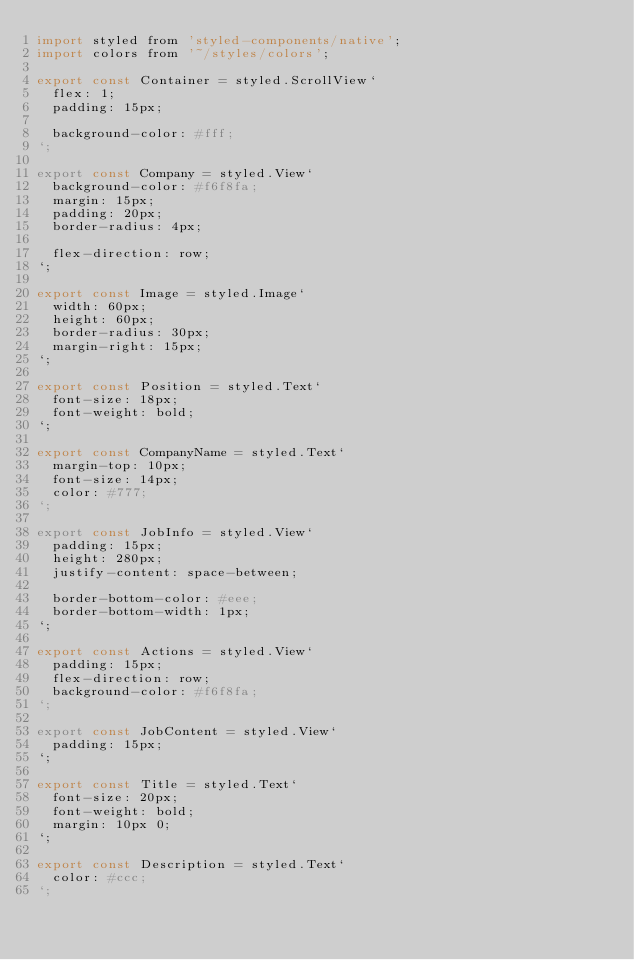<code> <loc_0><loc_0><loc_500><loc_500><_JavaScript_>import styled from 'styled-components/native';
import colors from '~/styles/colors';

export const Container = styled.ScrollView`
  flex: 1;
  padding: 15px;

  background-color: #fff;
`;

export const Company = styled.View`
  background-color: #f6f8fa;
  margin: 15px;
  padding: 20px;
  border-radius: 4px;

  flex-direction: row;
`;

export const Image = styled.Image`
  width: 60px;
  height: 60px;
  border-radius: 30px;
  margin-right: 15px;
`;

export const Position = styled.Text`
  font-size: 18px;
  font-weight: bold;
`;

export const CompanyName = styled.Text`
  margin-top: 10px;
  font-size: 14px;
  color: #777;
`;

export const JobInfo = styled.View`
  padding: 15px;
  height: 280px;
  justify-content: space-between;

  border-bottom-color: #eee;
  border-bottom-width: 1px;
`;

export const Actions = styled.View`
  padding: 15px;
  flex-direction: row;
  background-color: #f6f8fa;
`;

export const JobContent = styled.View`
  padding: 15px;
`;

export const Title = styled.Text`
  font-size: 20px;
  font-weight: bold;
  margin: 10px 0;
`;

export const Description = styled.Text`
  color: #ccc;
`;
</code> 